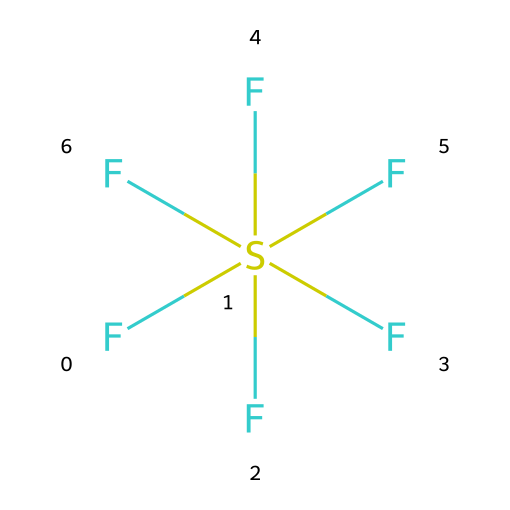What is the molecular formula of sulfur hexafluoride? The molecular formula is derived from the SMILES representation, which shows one sulfur atom and six fluorine atoms. Thus, the molecular formula is SF6.
Answer: SF6 How many fluorine atoms are bonded to sulfur? The visual representation includes six fluorine atoms directly bonded to a central sulfur atom, indicated by the multiple connections to the sulfur in the SMILES notation.
Answer: six What is the molecular geometry of sulfur hexafluoride? The arrangement of six fluorine atoms around the central sulfur atom suggests an octahedral geometry, which is typical for hypervalent compounds with six bonding pairs.
Answer: octahedral Does sulfur hexafluoride have lone pairs on sulfur? The structure indicates that all valence electrons of sulfur are used in bonding with fluorine atoms, leaving no lone pairs on the central sulfur atom.
Answer: no What type of bond exists between sulfur and fluorine in SF6? The connections between the sulfur and fluorine atoms are single covalent bonds, as each fluorine shares one of its electrons with sulfur to form a stable compound.
Answer: single covalent bonds Is sulfur hexafluoride polar or nonpolar? The symmetrical octahedral geometry and equivalent fluorine atoms result in a cancellation of dipole moments, making the molecule nonpolar overall.
Answer: nonpolar 